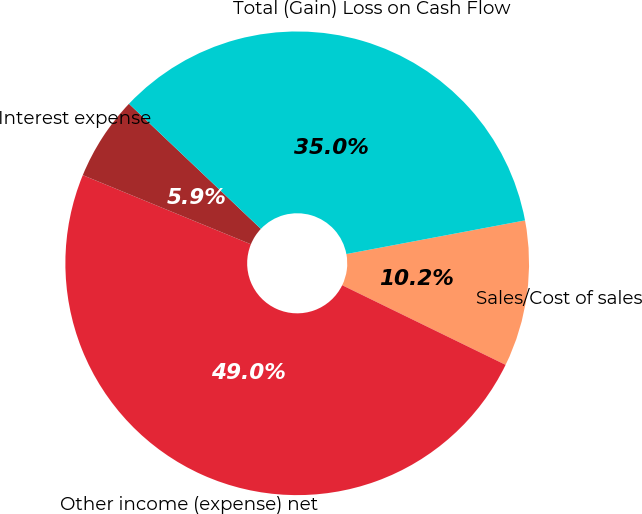Convert chart. <chart><loc_0><loc_0><loc_500><loc_500><pie_chart><fcel>Sales/Cost of sales<fcel>Other income (expense) net<fcel>Interest expense<fcel>Total (Gain) Loss on Cash Flow<nl><fcel>10.18%<fcel>48.99%<fcel>5.87%<fcel>34.96%<nl></chart> 